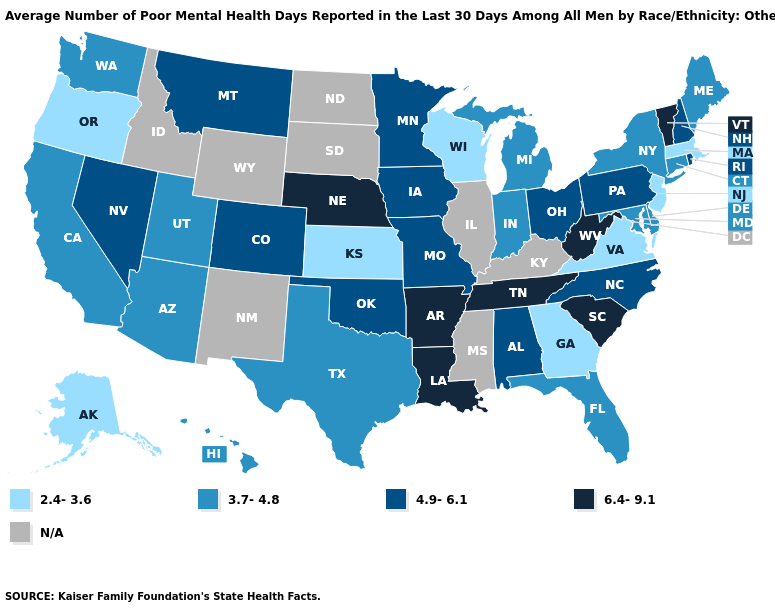Which states have the lowest value in the West?
Give a very brief answer. Alaska, Oregon. Among the states that border Louisiana , which have the highest value?
Answer briefly. Arkansas. What is the highest value in the USA?
Concise answer only. 6.4-9.1. What is the highest value in the Northeast ?
Keep it brief. 6.4-9.1. Which states have the highest value in the USA?
Answer briefly. Arkansas, Louisiana, Nebraska, South Carolina, Tennessee, Vermont, West Virginia. Among the states that border Wisconsin , does Michigan have the highest value?
Give a very brief answer. No. Name the states that have a value in the range 3.7-4.8?
Answer briefly. Arizona, California, Connecticut, Delaware, Florida, Hawaii, Indiana, Maine, Maryland, Michigan, New York, Texas, Utah, Washington. What is the value of Vermont?
Write a very short answer. 6.4-9.1. Name the states that have a value in the range 6.4-9.1?
Quick response, please. Arkansas, Louisiana, Nebraska, South Carolina, Tennessee, Vermont, West Virginia. What is the value of Rhode Island?
Concise answer only. 4.9-6.1. Name the states that have a value in the range 3.7-4.8?
Write a very short answer. Arizona, California, Connecticut, Delaware, Florida, Hawaii, Indiana, Maine, Maryland, Michigan, New York, Texas, Utah, Washington. Does the map have missing data?
Keep it brief. Yes. Does Oklahoma have the highest value in the South?
Be succinct. No. 